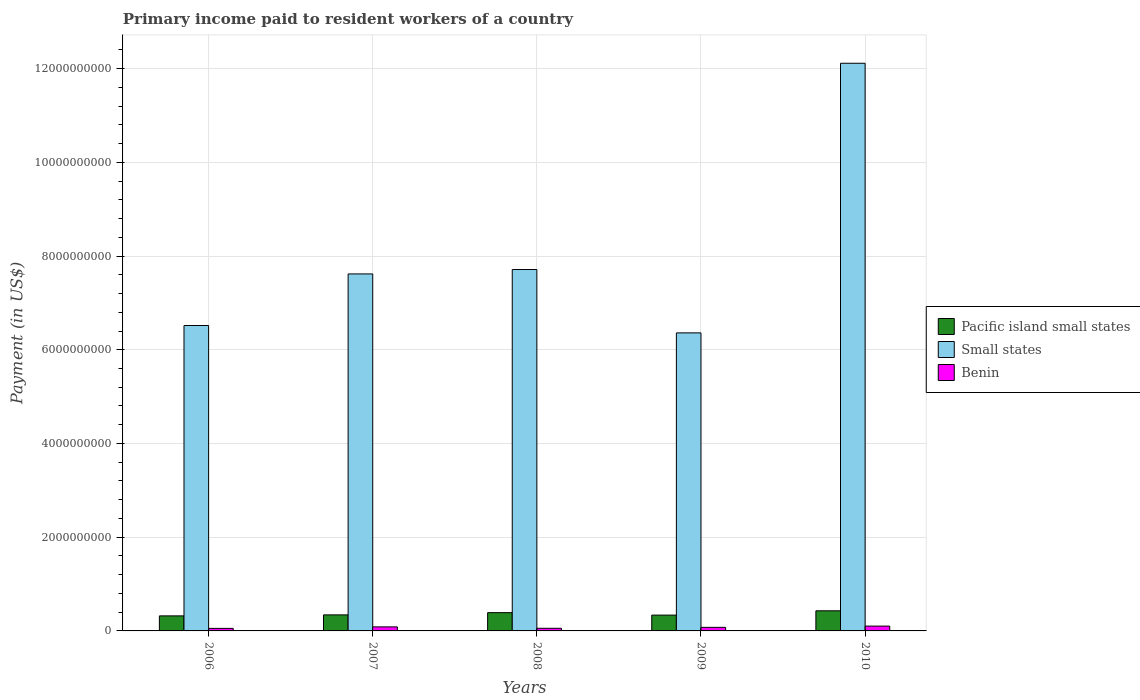How many groups of bars are there?
Your response must be concise. 5. Are the number of bars per tick equal to the number of legend labels?
Make the answer very short. Yes. How many bars are there on the 4th tick from the right?
Your answer should be very brief. 3. What is the label of the 2nd group of bars from the left?
Make the answer very short. 2007. What is the amount paid to workers in Small states in 2007?
Your response must be concise. 7.62e+09. Across all years, what is the maximum amount paid to workers in Small states?
Keep it short and to the point. 1.21e+1. Across all years, what is the minimum amount paid to workers in Small states?
Ensure brevity in your answer.  6.36e+09. In which year was the amount paid to workers in Pacific island small states minimum?
Your response must be concise. 2006. What is the total amount paid to workers in Benin in the graph?
Make the answer very short. 3.75e+08. What is the difference between the amount paid to workers in Small states in 2008 and that in 2010?
Your answer should be compact. -4.40e+09. What is the difference between the amount paid to workers in Small states in 2007 and the amount paid to workers in Benin in 2008?
Give a very brief answer. 7.56e+09. What is the average amount paid to workers in Small states per year?
Make the answer very short. 8.06e+09. In the year 2008, what is the difference between the amount paid to workers in Benin and amount paid to workers in Pacific island small states?
Provide a succinct answer. -3.34e+08. In how many years, is the amount paid to workers in Small states greater than 7200000000 US$?
Give a very brief answer. 3. What is the ratio of the amount paid to workers in Small states in 2007 to that in 2008?
Your answer should be very brief. 0.99. What is the difference between the highest and the second highest amount paid to workers in Pacific island small states?
Offer a terse response. 3.93e+07. What is the difference between the highest and the lowest amount paid to workers in Benin?
Make the answer very short. 4.88e+07. What does the 2nd bar from the left in 2008 represents?
Your answer should be compact. Small states. What does the 3rd bar from the right in 2009 represents?
Ensure brevity in your answer.  Pacific island small states. How many years are there in the graph?
Provide a succinct answer. 5. What is the difference between two consecutive major ticks on the Y-axis?
Provide a succinct answer. 2.00e+09. Does the graph contain any zero values?
Offer a very short reply. No. Does the graph contain grids?
Give a very brief answer. Yes. Where does the legend appear in the graph?
Provide a short and direct response. Center right. What is the title of the graph?
Your answer should be compact. Primary income paid to resident workers of a country. What is the label or title of the X-axis?
Ensure brevity in your answer.  Years. What is the label or title of the Y-axis?
Make the answer very short. Payment (in US$). What is the Payment (in US$) in Pacific island small states in 2006?
Ensure brevity in your answer.  3.21e+08. What is the Payment (in US$) of Small states in 2006?
Your answer should be very brief. 6.52e+09. What is the Payment (in US$) of Benin in 2006?
Offer a very short reply. 5.40e+07. What is the Payment (in US$) of Pacific island small states in 2007?
Your answer should be very brief. 3.42e+08. What is the Payment (in US$) in Small states in 2007?
Keep it short and to the point. 7.62e+09. What is the Payment (in US$) of Benin in 2007?
Your answer should be very brief. 8.61e+07. What is the Payment (in US$) in Pacific island small states in 2008?
Your response must be concise. 3.90e+08. What is the Payment (in US$) of Small states in 2008?
Keep it short and to the point. 7.71e+09. What is the Payment (in US$) in Benin in 2008?
Your answer should be very brief. 5.62e+07. What is the Payment (in US$) of Pacific island small states in 2009?
Provide a short and direct response. 3.37e+08. What is the Payment (in US$) in Small states in 2009?
Ensure brevity in your answer.  6.36e+09. What is the Payment (in US$) in Benin in 2009?
Your response must be concise. 7.61e+07. What is the Payment (in US$) of Pacific island small states in 2010?
Offer a very short reply. 4.29e+08. What is the Payment (in US$) of Small states in 2010?
Provide a short and direct response. 1.21e+1. What is the Payment (in US$) of Benin in 2010?
Make the answer very short. 1.03e+08. Across all years, what is the maximum Payment (in US$) in Pacific island small states?
Give a very brief answer. 4.29e+08. Across all years, what is the maximum Payment (in US$) in Small states?
Provide a succinct answer. 1.21e+1. Across all years, what is the maximum Payment (in US$) in Benin?
Keep it short and to the point. 1.03e+08. Across all years, what is the minimum Payment (in US$) in Pacific island small states?
Provide a succinct answer. 3.21e+08. Across all years, what is the minimum Payment (in US$) in Small states?
Ensure brevity in your answer.  6.36e+09. Across all years, what is the minimum Payment (in US$) in Benin?
Offer a very short reply. 5.40e+07. What is the total Payment (in US$) in Pacific island small states in the graph?
Your response must be concise. 1.82e+09. What is the total Payment (in US$) in Small states in the graph?
Offer a very short reply. 4.03e+1. What is the total Payment (in US$) of Benin in the graph?
Ensure brevity in your answer.  3.75e+08. What is the difference between the Payment (in US$) of Pacific island small states in 2006 and that in 2007?
Make the answer very short. -2.16e+07. What is the difference between the Payment (in US$) of Small states in 2006 and that in 2007?
Offer a terse response. -1.10e+09. What is the difference between the Payment (in US$) of Benin in 2006 and that in 2007?
Your answer should be very brief. -3.20e+07. What is the difference between the Payment (in US$) in Pacific island small states in 2006 and that in 2008?
Keep it short and to the point. -6.93e+07. What is the difference between the Payment (in US$) of Small states in 2006 and that in 2008?
Offer a terse response. -1.19e+09. What is the difference between the Payment (in US$) in Benin in 2006 and that in 2008?
Your response must be concise. -2.17e+06. What is the difference between the Payment (in US$) of Pacific island small states in 2006 and that in 2009?
Keep it short and to the point. -1.67e+07. What is the difference between the Payment (in US$) of Small states in 2006 and that in 2009?
Offer a very short reply. 1.58e+08. What is the difference between the Payment (in US$) in Benin in 2006 and that in 2009?
Your answer should be compact. -2.20e+07. What is the difference between the Payment (in US$) of Pacific island small states in 2006 and that in 2010?
Provide a short and direct response. -1.09e+08. What is the difference between the Payment (in US$) of Small states in 2006 and that in 2010?
Ensure brevity in your answer.  -5.60e+09. What is the difference between the Payment (in US$) of Benin in 2006 and that in 2010?
Your answer should be compact. -4.88e+07. What is the difference between the Payment (in US$) of Pacific island small states in 2007 and that in 2008?
Provide a short and direct response. -4.78e+07. What is the difference between the Payment (in US$) of Small states in 2007 and that in 2008?
Provide a short and direct response. -9.41e+07. What is the difference between the Payment (in US$) of Benin in 2007 and that in 2008?
Provide a short and direct response. 2.99e+07. What is the difference between the Payment (in US$) in Pacific island small states in 2007 and that in 2009?
Offer a terse response. 4.83e+06. What is the difference between the Payment (in US$) in Small states in 2007 and that in 2009?
Offer a terse response. 1.26e+09. What is the difference between the Payment (in US$) of Benin in 2007 and that in 2009?
Make the answer very short. 9.99e+06. What is the difference between the Payment (in US$) in Pacific island small states in 2007 and that in 2010?
Provide a succinct answer. -8.70e+07. What is the difference between the Payment (in US$) of Small states in 2007 and that in 2010?
Your response must be concise. -4.50e+09. What is the difference between the Payment (in US$) of Benin in 2007 and that in 2010?
Ensure brevity in your answer.  -1.68e+07. What is the difference between the Payment (in US$) in Pacific island small states in 2008 and that in 2009?
Offer a very short reply. 5.26e+07. What is the difference between the Payment (in US$) in Small states in 2008 and that in 2009?
Give a very brief answer. 1.35e+09. What is the difference between the Payment (in US$) of Benin in 2008 and that in 2009?
Your answer should be very brief. -1.99e+07. What is the difference between the Payment (in US$) in Pacific island small states in 2008 and that in 2010?
Keep it short and to the point. -3.93e+07. What is the difference between the Payment (in US$) of Small states in 2008 and that in 2010?
Your answer should be compact. -4.40e+09. What is the difference between the Payment (in US$) in Benin in 2008 and that in 2010?
Your response must be concise. -4.67e+07. What is the difference between the Payment (in US$) in Pacific island small states in 2009 and that in 2010?
Your answer should be compact. -9.19e+07. What is the difference between the Payment (in US$) of Small states in 2009 and that in 2010?
Provide a succinct answer. -5.75e+09. What is the difference between the Payment (in US$) in Benin in 2009 and that in 2010?
Make the answer very short. -2.68e+07. What is the difference between the Payment (in US$) of Pacific island small states in 2006 and the Payment (in US$) of Small states in 2007?
Offer a terse response. -7.30e+09. What is the difference between the Payment (in US$) in Pacific island small states in 2006 and the Payment (in US$) in Benin in 2007?
Your answer should be very brief. 2.35e+08. What is the difference between the Payment (in US$) in Small states in 2006 and the Payment (in US$) in Benin in 2007?
Give a very brief answer. 6.43e+09. What is the difference between the Payment (in US$) of Pacific island small states in 2006 and the Payment (in US$) of Small states in 2008?
Provide a succinct answer. -7.39e+09. What is the difference between the Payment (in US$) of Pacific island small states in 2006 and the Payment (in US$) of Benin in 2008?
Your response must be concise. 2.65e+08. What is the difference between the Payment (in US$) of Small states in 2006 and the Payment (in US$) of Benin in 2008?
Provide a succinct answer. 6.46e+09. What is the difference between the Payment (in US$) of Pacific island small states in 2006 and the Payment (in US$) of Small states in 2009?
Make the answer very short. -6.04e+09. What is the difference between the Payment (in US$) in Pacific island small states in 2006 and the Payment (in US$) in Benin in 2009?
Offer a terse response. 2.45e+08. What is the difference between the Payment (in US$) of Small states in 2006 and the Payment (in US$) of Benin in 2009?
Your answer should be compact. 6.44e+09. What is the difference between the Payment (in US$) of Pacific island small states in 2006 and the Payment (in US$) of Small states in 2010?
Your answer should be compact. -1.18e+1. What is the difference between the Payment (in US$) of Pacific island small states in 2006 and the Payment (in US$) of Benin in 2010?
Your answer should be very brief. 2.18e+08. What is the difference between the Payment (in US$) of Small states in 2006 and the Payment (in US$) of Benin in 2010?
Your answer should be very brief. 6.42e+09. What is the difference between the Payment (in US$) of Pacific island small states in 2007 and the Payment (in US$) of Small states in 2008?
Your response must be concise. -7.37e+09. What is the difference between the Payment (in US$) in Pacific island small states in 2007 and the Payment (in US$) in Benin in 2008?
Make the answer very short. 2.86e+08. What is the difference between the Payment (in US$) of Small states in 2007 and the Payment (in US$) of Benin in 2008?
Provide a short and direct response. 7.56e+09. What is the difference between the Payment (in US$) of Pacific island small states in 2007 and the Payment (in US$) of Small states in 2009?
Your answer should be very brief. -6.02e+09. What is the difference between the Payment (in US$) in Pacific island small states in 2007 and the Payment (in US$) in Benin in 2009?
Your answer should be very brief. 2.66e+08. What is the difference between the Payment (in US$) in Small states in 2007 and the Payment (in US$) in Benin in 2009?
Your answer should be compact. 7.54e+09. What is the difference between the Payment (in US$) in Pacific island small states in 2007 and the Payment (in US$) in Small states in 2010?
Keep it short and to the point. -1.18e+1. What is the difference between the Payment (in US$) in Pacific island small states in 2007 and the Payment (in US$) in Benin in 2010?
Your answer should be compact. 2.39e+08. What is the difference between the Payment (in US$) of Small states in 2007 and the Payment (in US$) of Benin in 2010?
Your response must be concise. 7.52e+09. What is the difference between the Payment (in US$) of Pacific island small states in 2008 and the Payment (in US$) of Small states in 2009?
Ensure brevity in your answer.  -5.97e+09. What is the difference between the Payment (in US$) in Pacific island small states in 2008 and the Payment (in US$) in Benin in 2009?
Provide a short and direct response. 3.14e+08. What is the difference between the Payment (in US$) of Small states in 2008 and the Payment (in US$) of Benin in 2009?
Offer a very short reply. 7.64e+09. What is the difference between the Payment (in US$) of Pacific island small states in 2008 and the Payment (in US$) of Small states in 2010?
Ensure brevity in your answer.  -1.17e+1. What is the difference between the Payment (in US$) of Pacific island small states in 2008 and the Payment (in US$) of Benin in 2010?
Offer a very short reply. 2.87e+08. What is the difference between the Payment (in US$) in Small states in 2008 and the Payment (in US$) in Benin in 2010?
Keep it short and to the point. 7.61e+09. What is the difference between the Payment (in US$) in Pacific island small states in 2009 and the Payment (in US$) in Small states in 2010?
Keep it short and to the point. -1.18e+1. What is the difference between the Payment (in US$) of Pacific island small states in 2009 and the Payment (in US$) of Benin in 2010?
Ensure brevity in your answer.  2.35e+08. What is the difference between the Payment (in US$) of Small states in 2009 and the Payment (in US$) of Benin in 2010?
Provide a succinct answer. 6.26e+09. What is the average Payment (in US$) of Pacific island small states per year?
Provide a short and direct response. 3.64e+08. What is the average Payment (in US$) in Small states per year?
Make the answer very short. 8.06e+09. What is the average Payment (in US$) in Benin per year?
Offer a terse response. 7.51e+07. In the year 2006, what is the difference between the Payment (in US$) of Pacific island small states and Payment (in US$) of Small states?
Your response must be concise. -6.20e+09. In the year 2006, what is the difference between the Payment (in US$) in Pacific island small states and Payment (in US$) in Benin?
Your answer should be compact. 2.67e+08. In the year 2006, what is the difference between the Payment (in US$) in Small states and Payment (in US$) in Benin?
Give a very brief answer. 6.46e+09. In the year 2007, what is the difference between the Payment (in US$) in Pacific island small states and Payment (in US$) in Small states?
Your response must be concise. -7.28e+09. In the year 2007, what is the difference between the Payment (in US$) in Pacific island small states and Payment (in US$) in Benin?
Provide a succinct answer. 2.56e+08. In the year 2007, what is the difference between the Payment (in US$) in Small states and Payment (in US$) in Benin?
Ensure brevity in your answer.  7.53e+09. In the year 2008, what is the difference between the Payment (in US$) of Pacific island small states and Payment (in US$) of Small states?
Make the answer very short. -7.32e+09. In the year 2008, what is the difference between the Payment (in US$) in Pacific island small states and Payment (in US$) in Benin?
Provide a short and direct response. 3.34e+08. In the year 2008, what is the difference between the Payment (in US$) of Small states and Payment (in US$) of Benin?
Offer a terse response. 7.66e+09. In the year 2009, what is the difference between the Payment (in US$) in Pacific island small states and Payment (in US$) in Small states?
Provide a short and direct response. -6.02e+09. In the year 2009, what is the difference between the Payment (in US$) in Pacific island small states and Payment (in US$) in Benin?
Your answer should be very brief. 2.61e+08. In the year 2009, what is the difference between the Payment (in US$) of Small states and Payment (in US$) of Benin?
Make the answer very short. 6.28e+09. In the year 2010, what is the difference between the Payment (in US$) of Pacific island small states and Payment (in US$) of Small states?
Give a very brief answer. -1.17e+1. In the year 2010, what is the difference between the Payment (in US$) of Pacific island small states and Payment (in US$) of Benin?
Your response must be concise. 3.26e+08. In the year 2010, what is the difference between the Payment (in US$) of Small states and Payment (in US$) of Benin?
Make the answer very short. 1.20e+1. What is the ratio of the Payment (in US$) in Pacific island small states in 2006 to that in 2007?
Provide a short and direct response. 0.94. What is the ratio of the Payment (in US$) in Small states in 2006 to that in 2007?
Your answer should be very brief. 0.86. What is the ratio of the Payment (in US$) in Benin in 2006 to that in 2007?
Keep it short and to the point. 0.63. What is the ratio of the Payment (in US$) of Pacific island small states in 2006 to that in 2008?
Your response must be concise. 0.82. What is the ratio of the Payment (in US$) in Small states in 2006 to that in 2008?
Provide a succinct answer. 0.85. What is the ratio of the Payment (in US$) in Benin in 2006 to that in 2008?
Offer a very short reply. 0.96. What is the ratio of the Payment (in US$) of Pacific island small states in 2006 to that in 2009?
Your answer should be very brief. 0.95. What is the ratio of the Payment (in US$) in Small states in 2006 to that in 2009?
Provide a short and direct response. 1.02. What is the ratio of the Payment (in US$) in Benin in 2006 to that in 2009?
Give a very brief answer. 0.71. What is the ratio of the Payment (in US$) of Pacific island small states in 2006 to that in 2010?
Give a very brief answer. 0.75. What is the ratio of the Payment (in US$) in Small states in 2006 to that in 2010?
Provide a short and direct response. 0.54. What is the ratio of the Payment (in US$) in Benin in 2006 to that in 2010?
Make the answer very short. 0.53. What is the ratio of the Payment (in US$) of Pacific island small states in 2007 to that in 2008?
Keep it short and to the point. 0.88. What is the ratio of the Payment (in US$) of Benin in 2007 to that in 2008?
Give a very brief answer. 1.53. What is the ratio of the Payment (in US$) of Pacific island small states in 2007 to that in 2009?
Your answer should be very brief. 1.01. What is the ratio of the Payment (in US$) of Small states in 2007 to that in 2009?
Ensure brevity in your answer.  1.2. What is the ratio of the Payment (in US$) of Benin in 2007 to that in 2009?
Provide a succinct answer. 1.13. What is the ratio of the Payment (in US$) of Pacific island small states in 2007 to that in 2010?
Your answer should be very brief. 0.8. What is the ratio of the Payment (in US$) in Small states in 2007 to that in 2010?
Your response must be concise. 0.63. What is the ratio of the Payment (in US$) of Benin in 2007 to that in 2010?
Make the answer very short. 0.84. What is the ratio of the Payment (in US$) in Pacific island small states in 2008 to that in 2009?
Provide a succinct answer. 1.16. What is the ratio of the Payment (in US$) of Small states in 2008 to that in 2009?
Provide a succinct answer. 1.21. What is the ratio of the Payment (in US$) of Benin in 2008 to that in 2009?
Your answer should be very brief. 0.74. What is the ratio of the Payment (in US$) in Pacific island small states in 2008 to that in 2010?
Offer a very short reply. 0.91. What is the ratio of the Payment (in US$) of Small states in 2008 to that in 2010?
Keep it short and to the point. 0.64. What is the ratio of the Payment (in US$) in Benin in 2008 to that in 2010?
Ensure brevity in your answer.  0.55. What is the ratio of the Payment (in US$) in Pacific island small states in 2009 to that in 2010?
Offer a terse response. 0.79. What is the ratio of the Payment (in US$) in Small states in 2009 to that in 2010?
Offer a very short reply. 0.53. What is the ratio of the Payment (in US$) in Benin in 2009 to that in 2010?
Your answer should be very brief. 0.74. What is the difference between the highest and the second highest Payment (in US$) in Pacific island small states?
Offer a terse response. 3.93e+07. What is the difference between the highest and the second highest Payment (in US$) of Small states?
Your answer should be compact. 4.40e+09. What is the difference between the highest and the second highest Payment (in US$) in Benin?
Make the answer very short. 1.68e+07. What is the difference between the highest and the lowest Payment (in US$) in Pacific island small states?
Keep it short and to the point. 1.09e+08. What is the difference between the highest and the lowest Payment (in US$) of Small states?
Keep it short and to the point. 5.75e+09. What is the difference between the highest and the lowest Payment (in US$) of Benin?
Make the answer very short. 4.88e+07. 